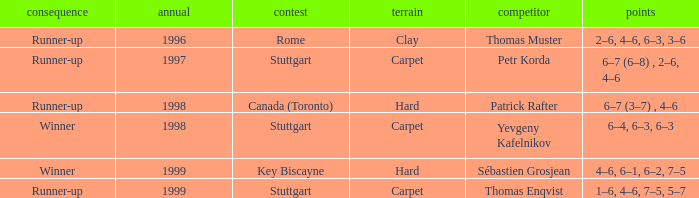What was the upshot preceding 1997? Runner-up. 